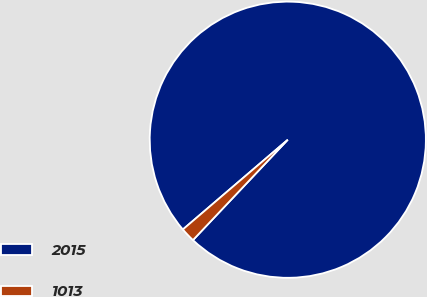Convert chart to OTSL. <chart><loc_0><loc_0><loc_500><loc_500><pie_chart><fcel>2015<fcel>1013<nl><fcel>98.31%<fcel>1.69%<nl></chart> 